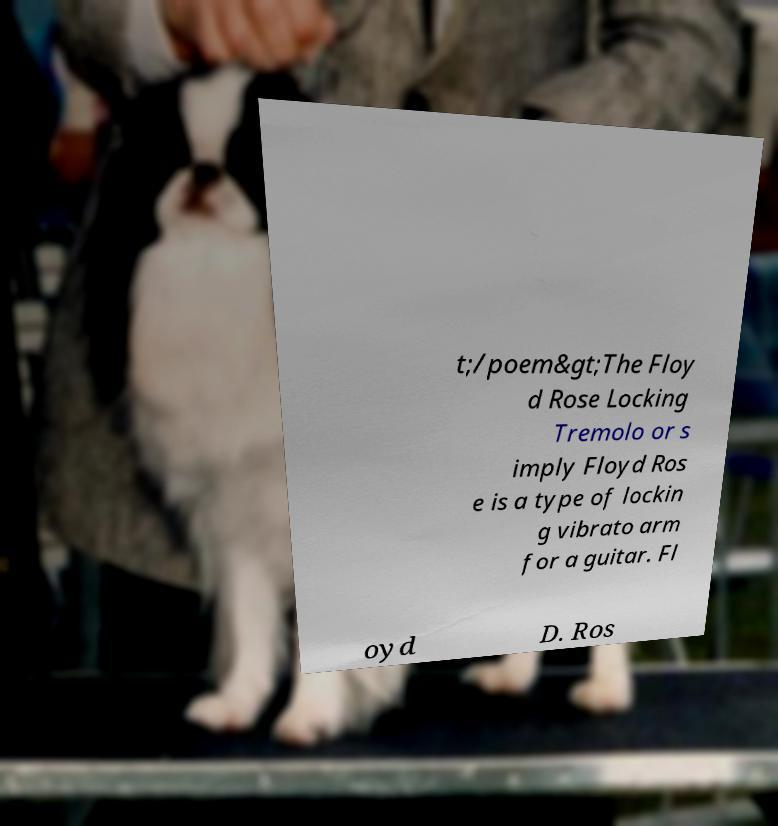Please read and relay the text visible in this image. What does it say? t;/poem&gt;The Floy d Rose Locking Tremolo or s imply Floyd Ros e is a type of lockin g vibrato arm for a guitar. Fl oyd D. Ros 